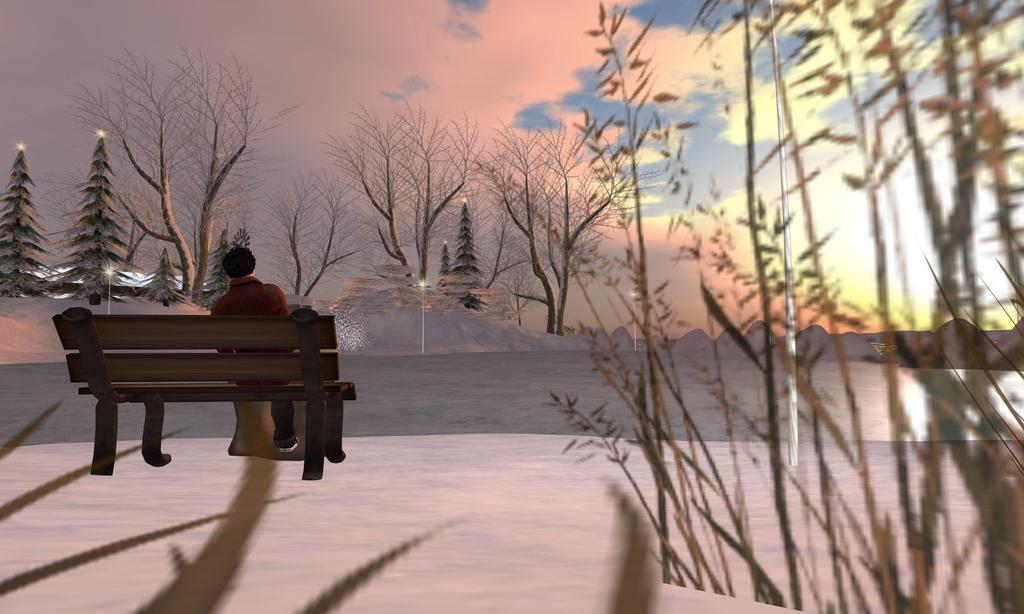What is the person in the image doing? There is a person sitting on a bench in the image. What type of vegetation can be seen in the image? There are plants and trees in the image. What structures are present in the image? There are poles in the image. What is visible in the background of the image? The sky is visible in the background of the image, and there are clouds in the sky. What type of sack does the fireman carry in the image? There is no fireman or sack present in the image. Who is the owner of the plants in the image? The image does not provide information about the ownership of the plants. 